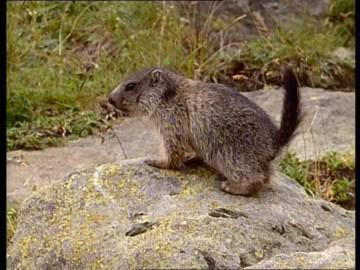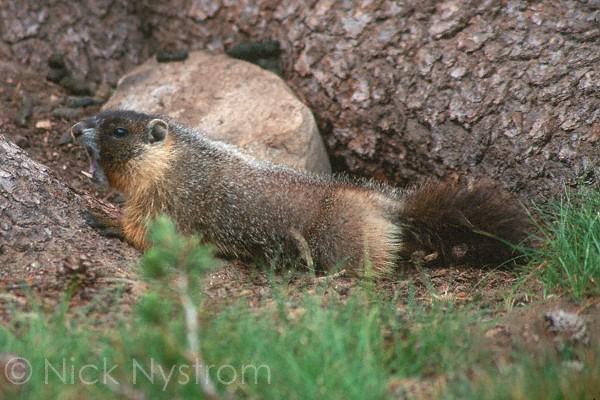The first image is the image on the left, the second image is the image on the right. Examine the images to the left and right. Is the description "There is a groundhog-like animal standing straight up with its paws in the air." accurate? Answer yes or no. No. 